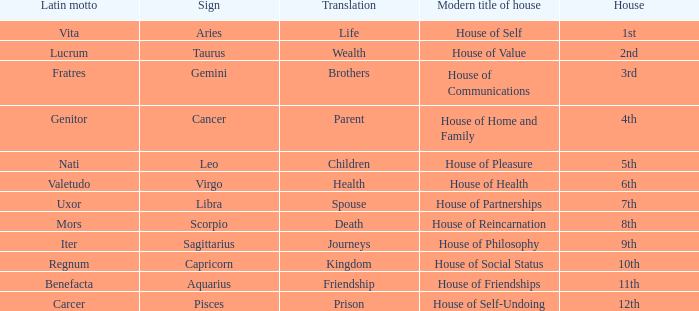What is the modern house title of the 1st house? House of Self. 